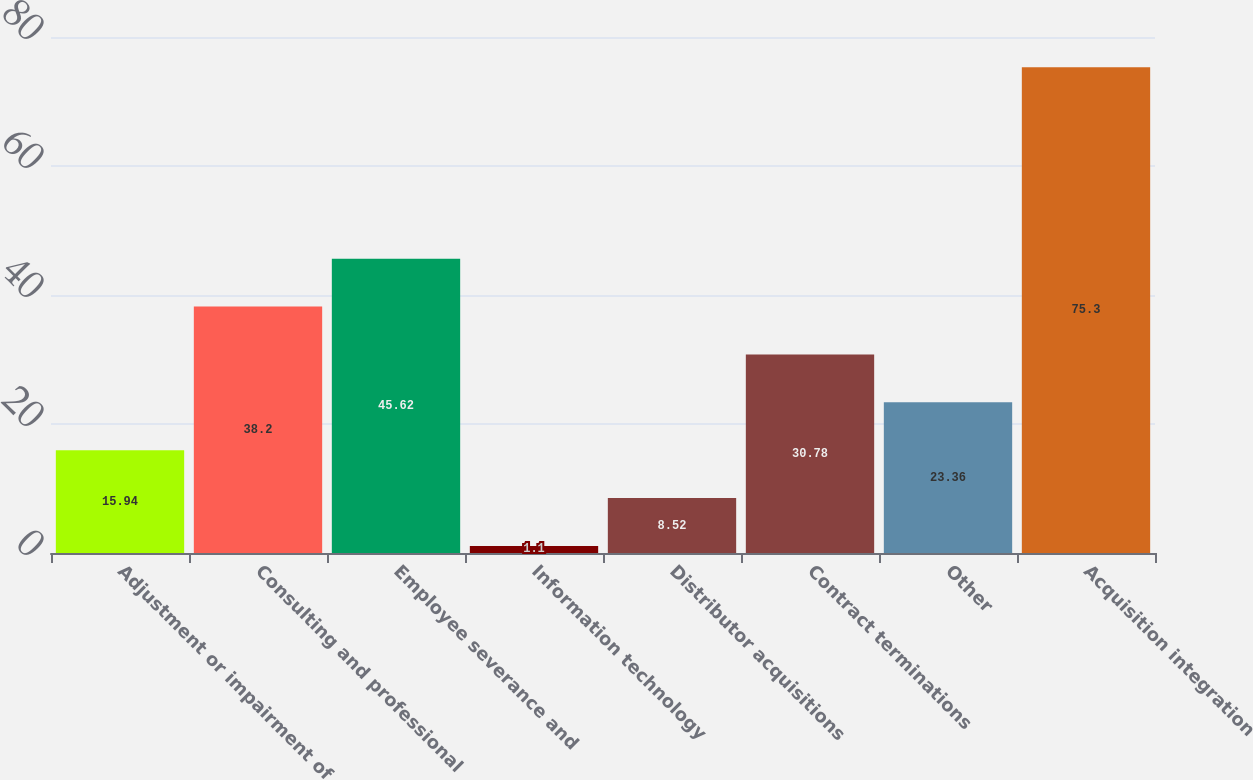<chart> <loc_0><loc_0><loc_500><loc_500><bar_chart><fcel>Adjustment or impairment of<fcel>Consulting and professional<fcel>Employee severance and<fcel>Information technology<fcel>Distributor acquisitions<fcel>Contract terminations<fcel>Other<fcel>Acquisition integration<nl><fcel>15.94<fcel>38.2<fcel>45.62<fcel>1.1<fcel>8.52<fcel>30.78<fcel>23.36<fcel>75.3<nl></chart> 